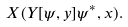Convert formula to latex. <formula><loc_0><loc_0><loc_500><loc_500>X ( Y [ \psi , y ] \psi ^ { * } , x ) .</formula> 